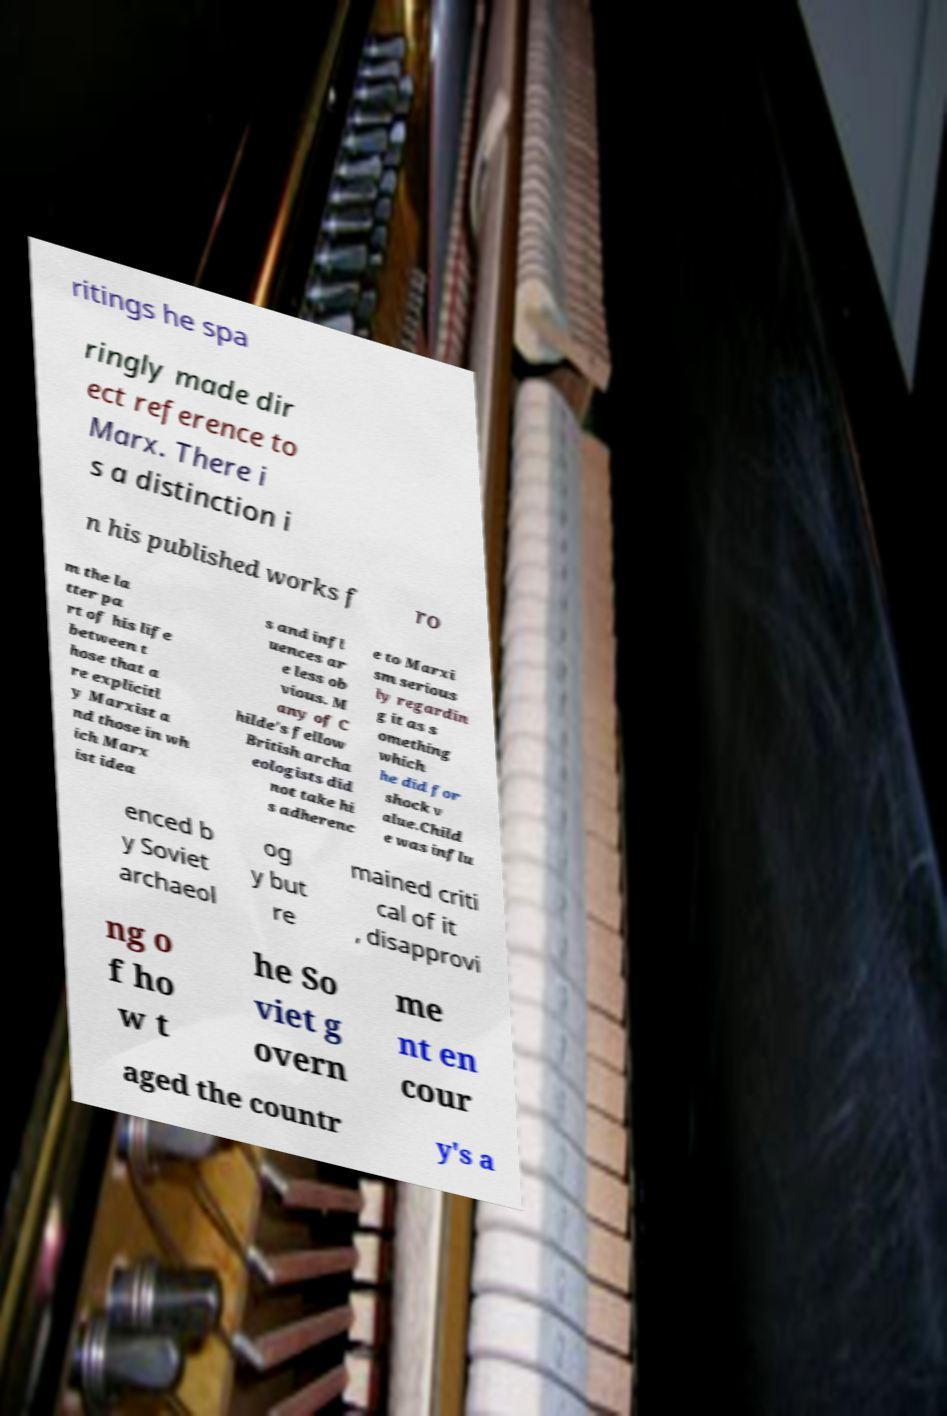Could you extract and type out the text from this image? ritings he spa ringly made dir ect reference to Marx. There i s a distinction i n his published works f ro m the la tter pa rt of his life between t hose that a re explicitl y Marxist a nd those in wh ich Marx ist idea s and infl uences ar e less ob vious. M any of C hilde's fellow British archa eologists did not take hi s adherenc e to Marxi sm serious ly regardin g it as s omething which he did for shock v alue.Child e was influ enced b y Soviet archaeol og y but re mained criti cal of it , disapprovi ng o f ho w t he So viet g overn me nt en cour aged the countr y's a 